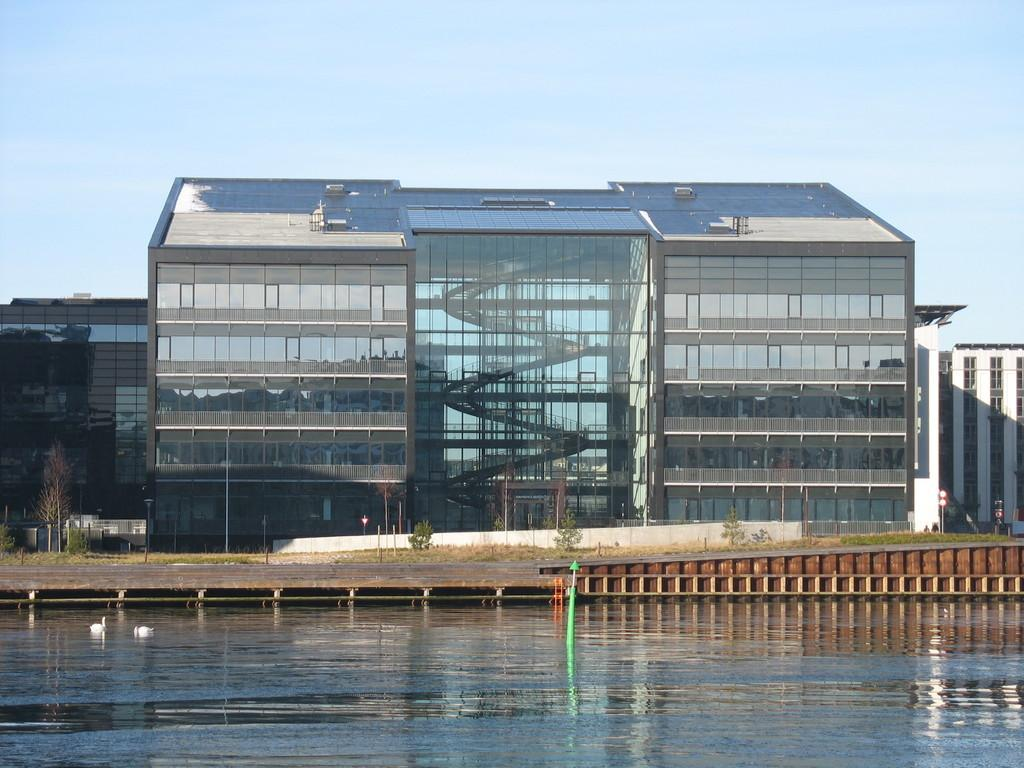How many birds can be seen in the image? There are two birds in the image. Where are the birds located? The birds are on the water. What type of vegetation is present in the image? There is grass and plants in the image. What type of structures can be seen in the image? There are buildings in the image. What else can be seen in the image besides the birds, vegetation, and buildings? There are some objects in the image. What is visible in the background of the image? The sky is visible in the background of the image. What type of wood is the bird sitting on in the image? There is no wood present in the image; the birds are on the water. What kind of insect is crawling on the bird's beak in the image? There are no insects visible in the image. 